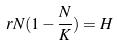Convert formula to latex. <formula><loc_0><loc_0><loc_500><loc_500>r N ( 1 - \frac { N } { K } ) = H</formula> 